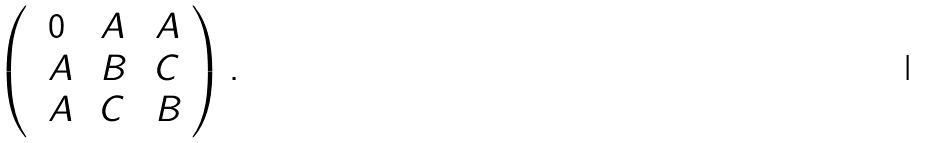<formula> <loc_0><loc_0><loc_500><loc_500>\left ( \begin{array} { l l l } \ 0 & \ A & \ A \\ \ A & \ B & \ C \\ \ A & \ C & \ B \\ \end{array} \right ) . \ \</formula> 